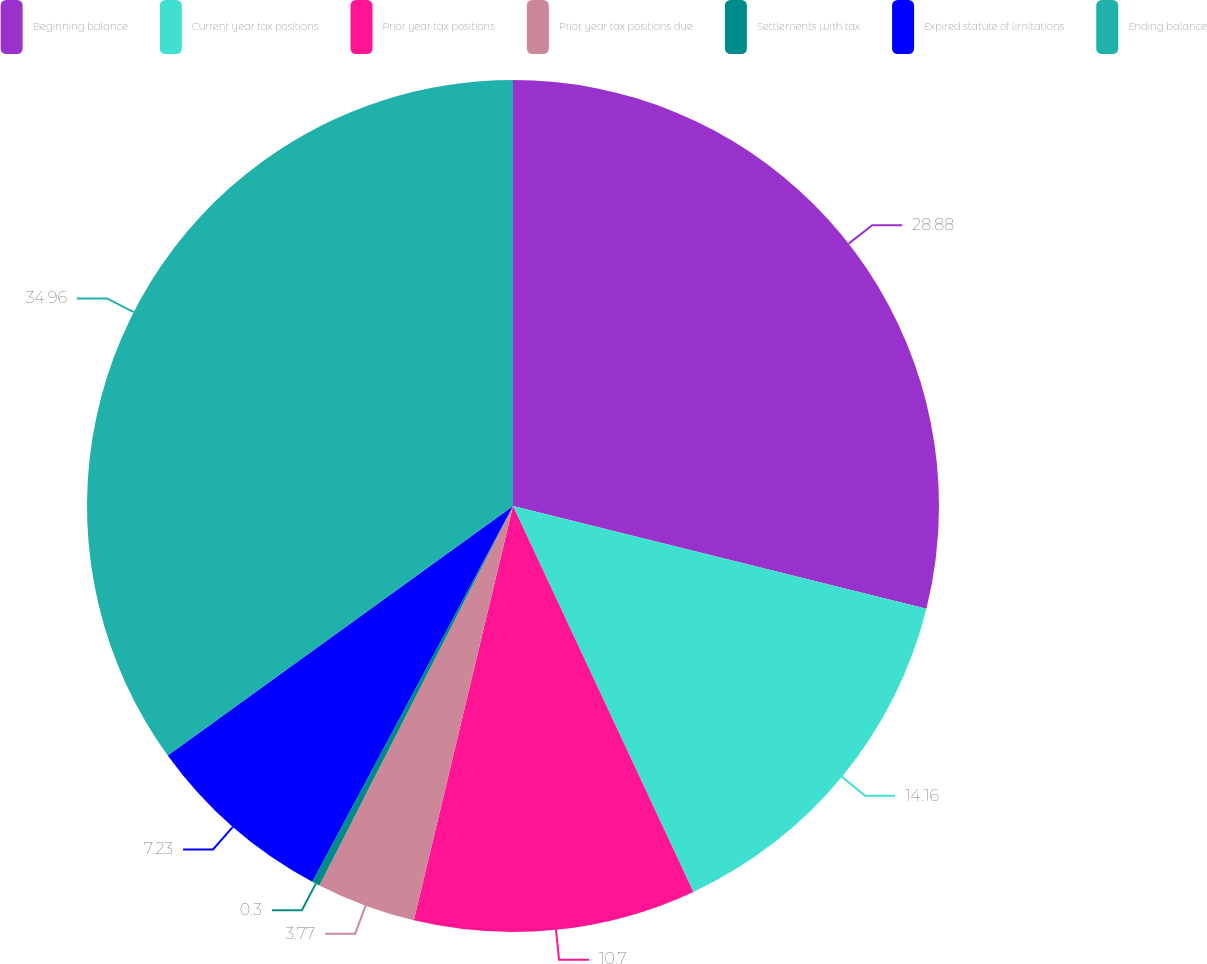Convert chart to OTSL. <chart><loc_0><loc_0><loc_500><loc_500><pie_chart><fcel>Beginning balance<fcel>Current year tax positions<fcel>Prior year tax positions<fcel>Prior year tax positions due<fcel>Settlements with tax<fcel>Expired statute of limitations<fcel>Ending balance<nl><fcel>28.88%<fcel>14.16%<fcel>10.7%<fcel>3.77%<fcel>0.3%<fcel>7.23%<fcel>34.96%<nl></chart> 